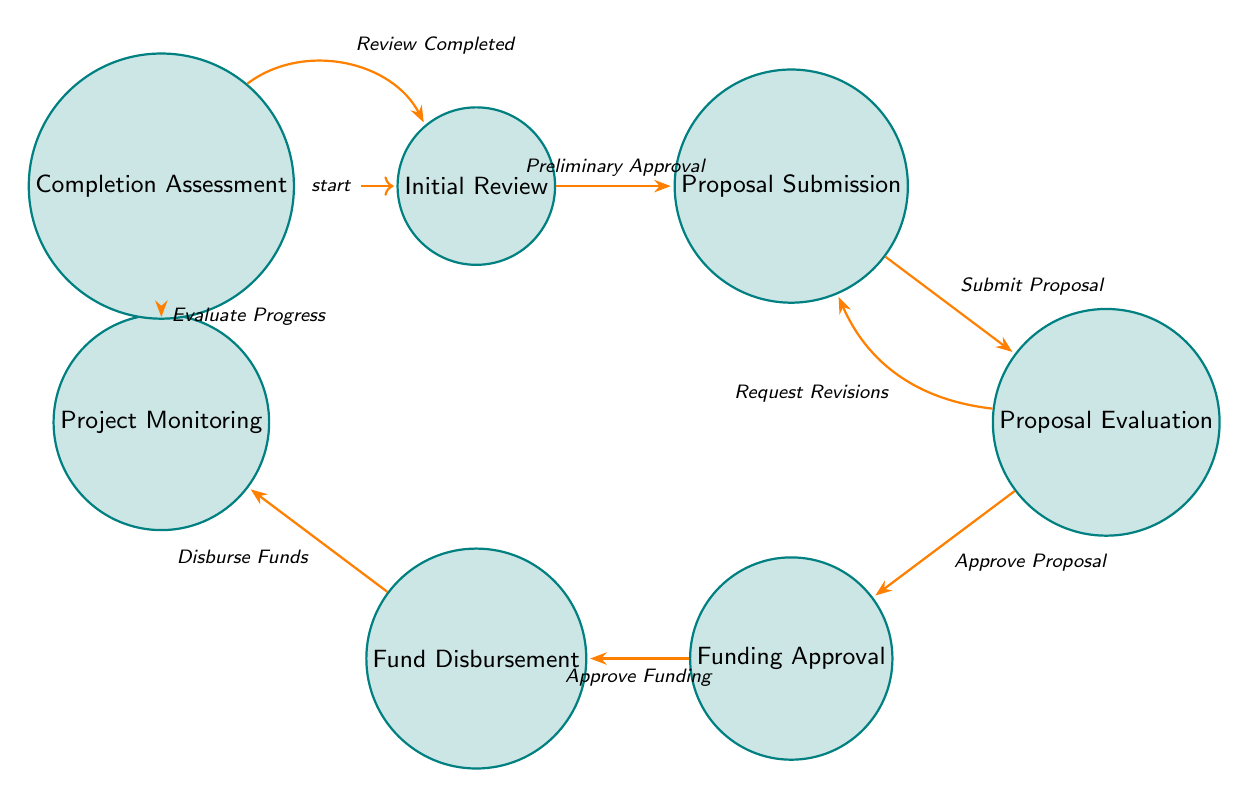What's the starting state of the process? The diagram indicates that the starting state is "Initial Review," which is marked as the initial node in the finite state machine.
Answer: Initial Review How many states are represented in the diagram? The diagram lists six distinct states, which are "Initial Review," "Proposal Submission," "Proposal Evaluation," "Funding Approval," "Fund Disbursement," "Project Monitoring," and "Completion Assessment."
Answer: Six What action leads from "Proposal Submission" to "Proposal Evaluation"? The transition from "Proposal Submission" to "Proposal Evaluation" occurs with the action "Submit Proposal." This action is shown along the directed edge connecting the two states.
Answer: Submit Proposal Which state follows "Funding Approval"? The state that directly follows "Funding Approval" in the diagram is "Fund Disbursement," illustrated by the directed transition from "Funding Approval" to "Fund Disbursement."
Answer: Fund Disbursement What happens after "Completion Assessment"? After "Completion Assessment," the process transitions back to "Initial Review" based on the action "Review Completed," indicating a feedback loop in the process.
Answer: Initial Review How many transitions are there in total? By counting the arrows in the diagram, there are eight distinct transitions, each representing the action between the states.
Answer: Eight What happens if the proposal is not approved during evaluation? If the proposal is not approved, the action "Request Revisions" directs the flow back to "Proposal Submission," indicating that revisions are needed before re-evaluating the proposal.
Answer: Request Revisions What is the first action that occurs in the process? The first action that occurs in the process is "Preliminary Approval," which transitions the state from "Initial Review" to "Proposal Submission."
Answer: Preliminary Approval 